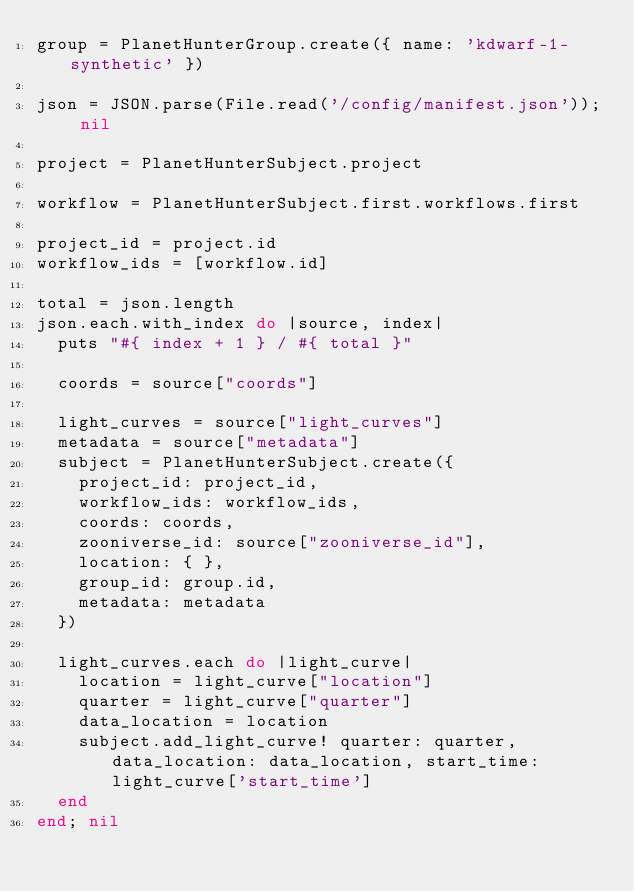<code> <loc_0><loc_0><loc_500><loc_500><_Ruby_>group = PlanetHunterGroup.create({ name: 'kdwarf-1-synthetic' })

json = JSON.parse(File.read('/config/manifest.json')); nil

project = PlanetHunterSubject.project

workflow = PlanetHunterSubject.first.workflows.first

project_id = project.id
workflow_ids = [workflow.id]

total = json.length
json.each.with_index do |source, index|
  puts "#{ index + 1 } / #{ total }"

  coords = source["coords"]

  light_curves = source["light_curves"]
  metadata = source["metadata"]
  subject = PlanetHunterSubject.create({
    project_id: project_id,
    workflow_ids: workflow_ids,
    coords: coords,
    zooniverse_id: source["zooniverse_id"],
    location: { },
    group_id: group.id,
    metadata: metadata
  })

  light_curves.each do |light_curve|
    location = light_curve["location"]
    quarter = light_curve["quarter"]
    data_location = location
    subject.add_light_curve! quarter: quarter, data_location: data_location, start_time: light_curve['start_time']
  end
end; nil
</code> 